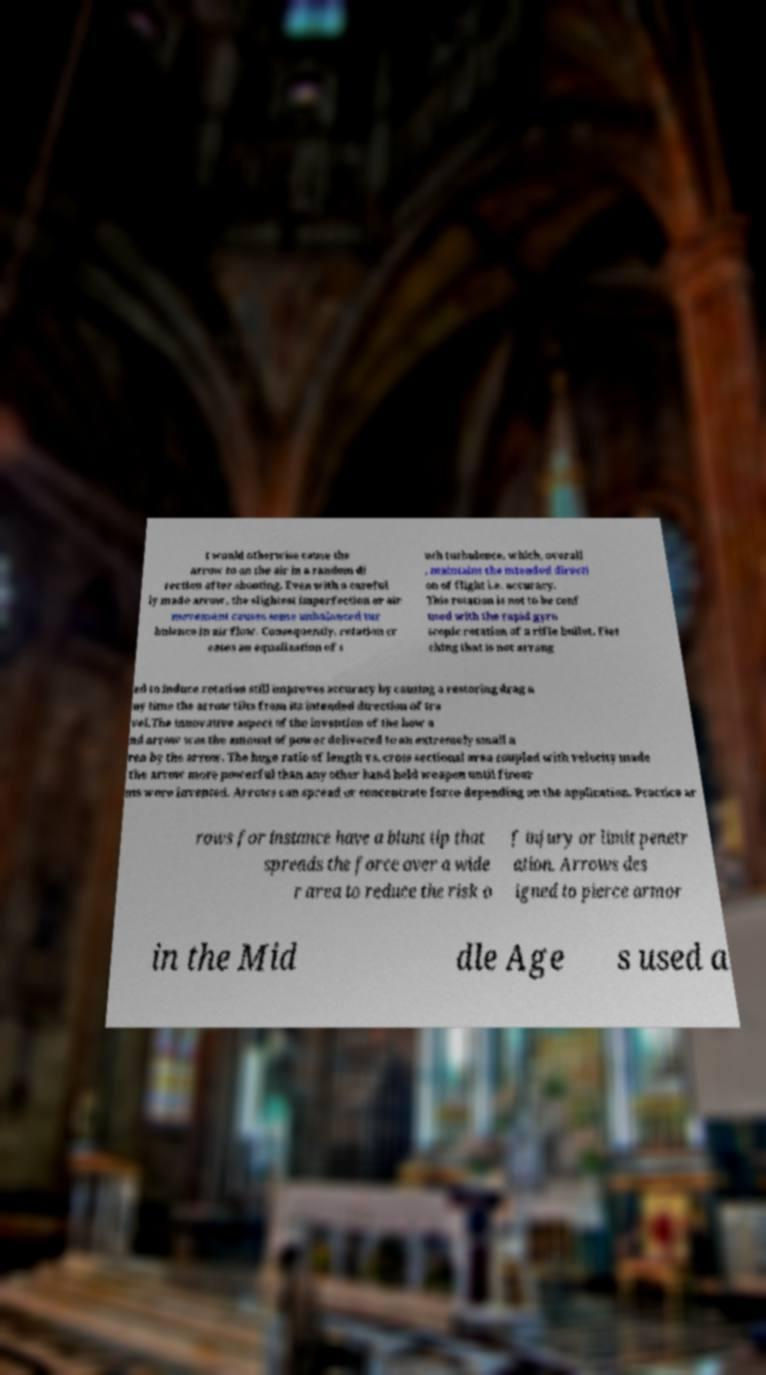There's text embedded in this image that I need extracted. Can you transcribe it verbatim? t would otherwise cause the arrow to on the air in a random di rection after shooting. Even with a careful ly made arrow, the slightest imperfection or air movement causes some unbalanced tur bulence in air flow. Consequently, rotation cr eates an equalization of s uch turbulence, which, overall , maintains the intended directi on of flight i.e. accuracy. This rotation is not to be conf used with the rapid gyro scopic rotation of a rifle bullet. Flet ching that is not arrang ed to induce rotation still improves accuracy by causing a restoring drag a ny time the arrow tilts from its intended direction of tra vel.The innovative aspect of the invention of the bow a nd arrow was the amount of power delivered to an extremely small a rea by the arrow. The huge ratio of length vs. cross sectional area coupled with velocity made the arrow more powerful than any other hand held weapon until firear ms were invented. Arrows can spread or concentrate force depending on the application. Practice ar rows for instance have a blunt tip that spreads the force over a wide r area to reduce the risk o f injury or limit penetr ation. Arrows des igned to pierce armor in the Mid dle Age s used a 